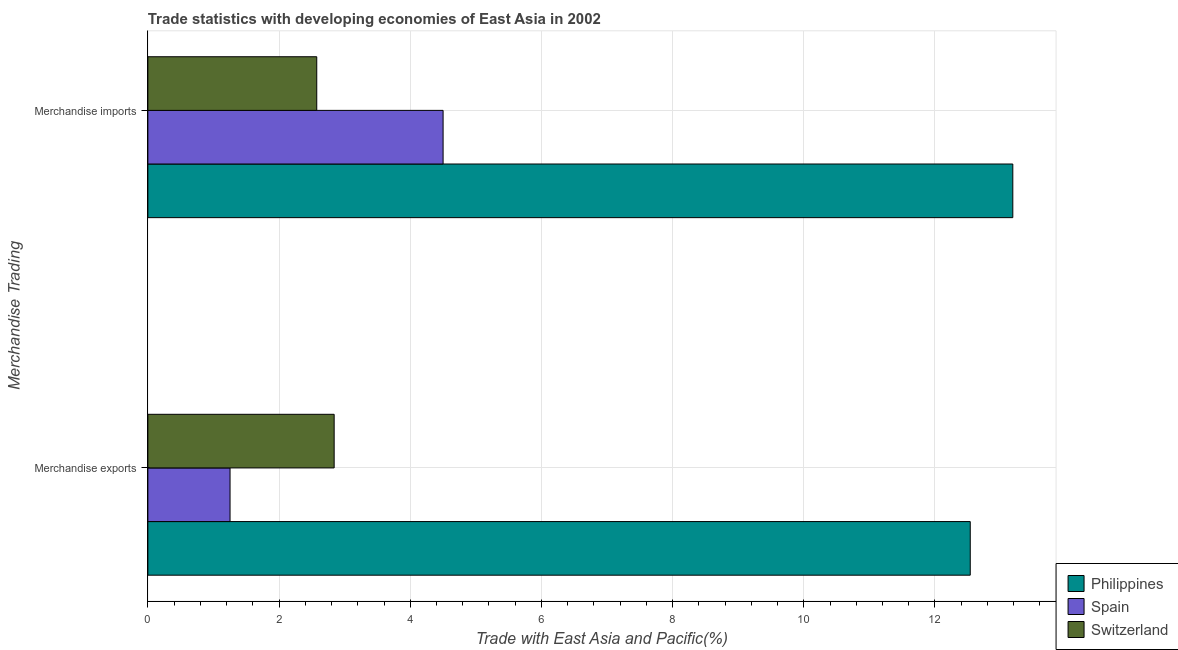How many different coloured bars are there?
Ensure brevity in your answer.  3. Are the number of bars per tick equal to the number of legend labels?
Ensure brevity in your answer.  Yes. Are the number of bars on each tick of the Y-axis equal?
Offer a very short reply. Yes. What is the merchandise imports in Spain?
Offer a terse response. 4.5. Across all countries, what is the maximum merchandise imports?
Offer a terse response. 13.19. Across all countries, what is the minimum merchandise imports?
Your answer should be very brief. 2.57. What is the total merchandise imports in the graph?
Provide a succinct answer. 20.26. What is the difference between the merchandise exports in Switzerland and that in Spain?
Your answer should be very brief. 1.59. What is the difference between the merchandise imports in Philippines and the merchandise exports in Switzerland?
Offer a terse response. 10.35. What is the average merchandise exports per country?
Your answer should be compact. 5.54. What is the difference between the merchandise exports and merchandise imports in Philippines?
Give a very brief answer. -0.65. In how many countries, is the merchandise exports greater than 4.8 %?
Give a very brief answer. 1. What is the ratio of the merchandise imports in Switzerland to that in Philippines?
Provide a short and direct response. 0.2. What does the 1st bar from the top in Merchandise imports represents?
Your answer should be compact. Switzerland. What does the 3rd bar from the bottom in Merchandise imports represents?
Keep it short and to the point. Switzerland. How many bars are there?
Provide a succinct answer. 6. Are the values on the major ticks of X-axis written in scientific E-notation?
Your answer should be compact. No. Where does the legend appear in the graph?
Provide a short and direct response. Bottom right. How many legend labels are there?
Provide a succinct answer. 3. How are the legend labels stacked?
Your answer should be very brief. Vertical. What is the title of the graph?
Your answer should be compact. Trade statistics with developing economies of East Asia in 2002. What is the label or title of the X-axis?
Provide a succinct answer. Trade with East Asia and Pacific(%). What is the label or title of the Y-axis?
Give a very brief answer. Merchandise Trading. What is the Trade with East Asia and Pacific(%) in Philippines in Merchandise exports?
Make the answer very short. 12.54. What is the Trade with East Asia and Pacific(%) in Spain in Merchandise exports?
Provide a succinct answer. 1.25. What is the Trade with East Asia and Pacific(%) in Switzerland in Merchandise exports?
Give a very brief answer. 2.84. What is the Trade with East Asia and Pacific(%) in Philippines in Merchandise imports?
Provide a short and direct response. 13.19. What is the Trade with East Asia and Pacific(%) in Spain in Merchandise imports?
Give a very brief answer. 4.5. What is the Trade with East Asia and Pacific(%) of Switzerland in Merchandise imports?
Make the answer very short. 2.57. Across all Merchandise Trading, what is the maximum Trade with East Asia and Pacific(%) in Philippines?
Your response must be concise. 13.19. Across all Merchandise Trading, what is the maximum Trade with East Asia and Pacific(%) in Spain?
Provide a short and direct response. 4.5. Across all Merchandise Trading, what is the maximum Trade with East Asia and Pacific(%) of Switzerland?
Offer a terse response. 2.84. Across all Merchandise Trading, what is the minimum Trade with East Asia and Pacific(%) of Philippines?
Offer a terse response. 12.54. Across all Merchandise Trading, what is the minimum Trade with East Asia and Pacific(%) of Spain?
Offer a terse response. 1.25. Across all Merchandise Trading, what is the minimum Trade with East Asia and Pacific(%) of Switzerland?
Keep it short and to the point. 2.57. What is the total Trade with East Asia and Pacific(%) of Philippines in the graph?
Your answer should be very brief. 25.72. What is the total Trade with East Asia and Pacific(%) in Spain in the graph?
Make the answer very short. 5.75. What is the total Trade with East Asia and Pacific(%) of Switzerland in the graph?
Ensure brevity in your answer.  5.41. What is the difference between the Trade with East Asia and Pacific(%) of Philippines in Merchandise exports and that in Merchandise imports?
Give a very brief answer. -0.65. What is the difference between the Trade with East Asia and Pacific(%) in Spain in Merchandise exports and that in Merchandise imports?
Ensure brevity in your answer.  -3.25. What is the difference between the Trade with East Asia and Pacific(%) in Switzerland in Merchandise exports and that in Merchandise imports?
Make the answer very short. 0.27. What is the difference between the Trade with East Asia and Pacific(%) of Philippines in Merchandise exports and the Trade with East Asia and Pacific(%) of Spain in Merchandise imports?
Ensure brevity in your answer.  8.04. What is the difference between the Trade with East Asia and Pacific(%) of Philippines in Merchandise exports and the Trade with East Asia and Pacific(%) of Switzerland in Merchandise imports?
Offer a very short reply. 9.96. What is the difference between the Trade with East Asia and Pacific(%) in Spain in Merchandise exports and the Trade with East Asia and Pacific(%) in Switzerland in Merchandise imports?
Your response must be concise. -1.32. What is the average Trade with East Asia and Pacific(%) of Philippines per Merchandise Trading?
Offer a very short reply. 12.86. What is the average Trade with East Asia and Pacific(%) in Spain per Merchandise Trading?
Ensure brevity in your answer.  2.88. What is the average Trade with East Asia and Pacific(%) in Switzerland per Merchandise Trading?
Offer a terse response. 2.71. What is the difference between the Trade with East Asia and Pacific(%) of Philippines and Trade with East Asia and Pacific(%) of Spain in Merchandise exports?
Keep it short and to the point. 11.29. What is the difference between the Trade with East Asia and Pacific(%) of Philippines and Trade with East Asia and Pacific(%) of Switzerland in Merchandise exports?
Ensure brevity in your answer.  9.7. What is the difference between the Trade with East Asia and Pacific(%) in Spain and Trade with East Asia and Pacific(%) in Switzerland in Merchandise exports?
Offer a very short reply. -1.59. What is the difference between the Trade with East Asia and Pacific(%) in Philippines and Trade with East Asia and Pacific(%) in Spain in Merchandise imports?
Make the answer very short. 8.69. What is the difference between the Trade with East Asia and Pacific(%) of Philippines and Trade with East Asia and Pacific(%) of Switzerland in Merchandise imports?
Offer a very short reply. 10.61. What is the difference between the Trade with East Asia and Pacific(%) in Spain and Trade with East Asia and Pacific(%) in Switzerland in Merchandise imports?
Provide a succinct answer. 1.93. What is the ratio of the Trade with East Asia and Pacific(%) in Philippines in Merchandise exports to that in Merchandise imports?
Your response must be concise. 0.95. What is the ratio of the Trade with East Asia and Pacific(%) in Spain in Merchandise exports to that in Merchandise imports?
Offer a very short reply. 0.28. What is the ratio of the Trade with East Asia and Pacific(%) of Switzerland in Merchandise exports to that in Merchandise imports?
Make the answer very short. 1.1. What is the difference between the highest and the second highest Trade with East Asia and Pacific(%) of Philippines?
Give a very brief answer. 0.65. What is the difference between the highest and the second highest Trade with East Asia and Pacific(%) in Spain?
Ensure brevity in your answer.  3.25. What is the difference between the highest and the second highest Trade with East Asia and Pacific(%) of Switzerland?
Provide a succinct answer. 0.27. What is the difference between the highest and the lowest Trade with East Asia and Pacific(%) in Philippines?
Your answer should be compact. 0.65. What is the difference between the highest and the lowest Trade with East Asia and Pacific(%) of Spain?
Ensure brevity in your answer.  3.25. What is the difference between the highest and the lowest Trade with East Asia and Pacific(%) in Switzerland?
Provide a succinct answer. 0.27. 